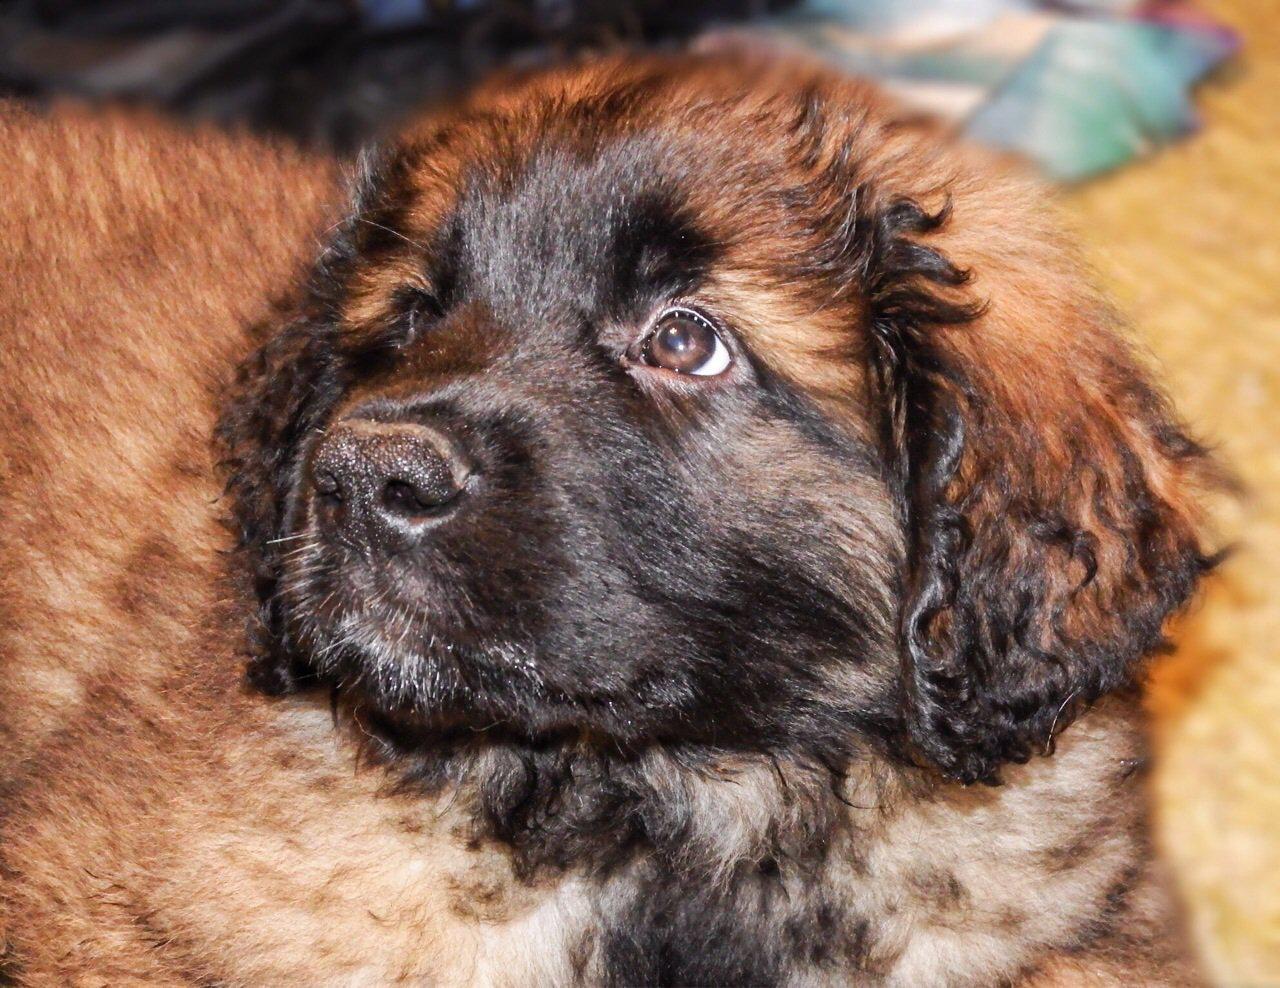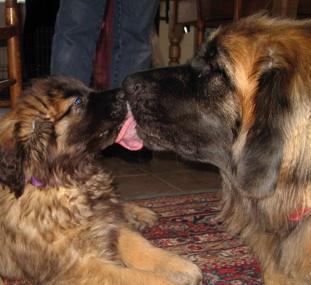The first image is the image on the left, the second image is the image on the right. Analyze the images presented: Is the assertion "There are two dogs, and one visible tongue." valid? Answer yes or no. No. The first image is the image on the left, the second image is the image on the right. For the images displayed, is the sentence "A larger animal is partly visible to the right of a puppy in an indoor setting." factually correct? Answer yes or no. Yes. 